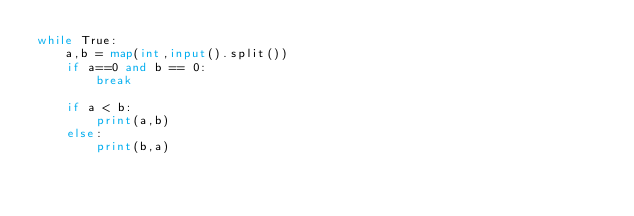Convert code to text. <code><loc_0><loc_0><loc_500><loc_500><_Python_>while True:
    a,b = map(int,input().split())
    if a==0 and b == 0:
        break
    
    if a < b:
        print(a,b)
    else:
        print(b,a)
</code> 